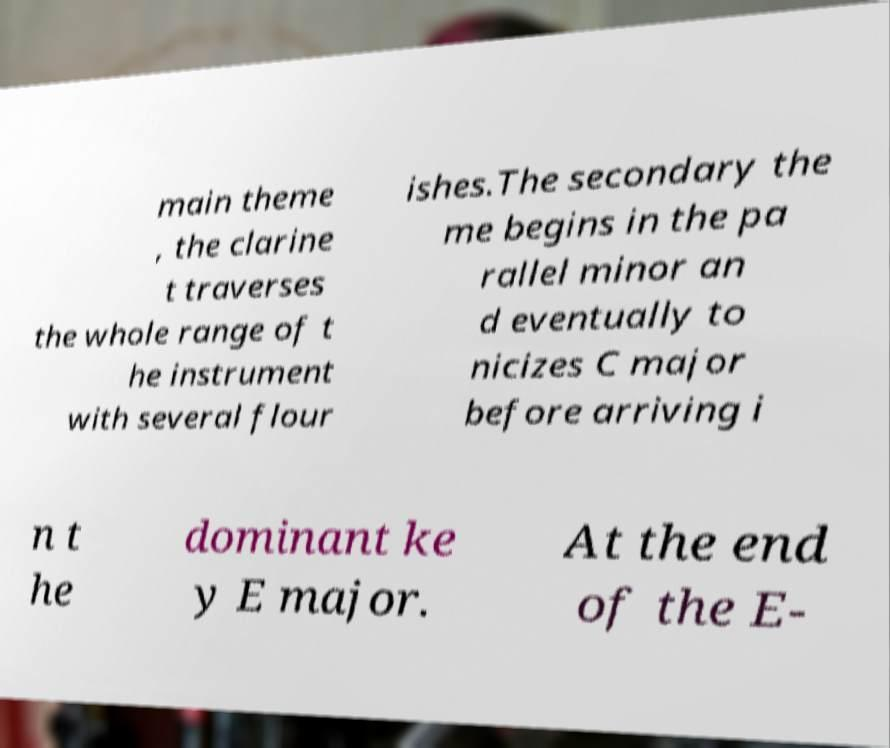Can you read and provide the text displayed in the image?This photo seems to have some interesting text. Can you extract and type it out for me? main theme , the clarine t traverses the whole range of t he instrument with several flour ishes.The secondary the me begins in the pa rallel minor an d eventually to nicizes C major before arriving i n t he dominant ke y E major. At the end of the E- 